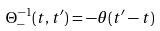Convert formula to latex. <formula><loc_0><loc_0><loc_500><loc_500>\Theta _ { - } ^ { - 1 } ( t , t ^ { \prime } ) = - \theta ( t ^ { \prime } - t )</formula> 